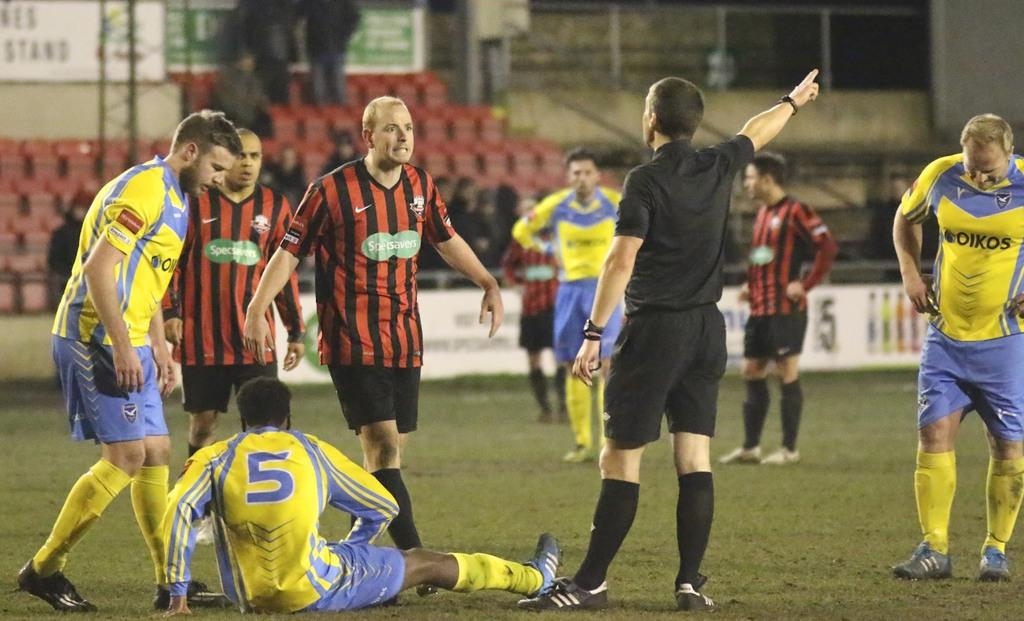<image>
Provide a brief description of the given image. A man sits on the field at a soccer game with a large five emblazoned on his back. 